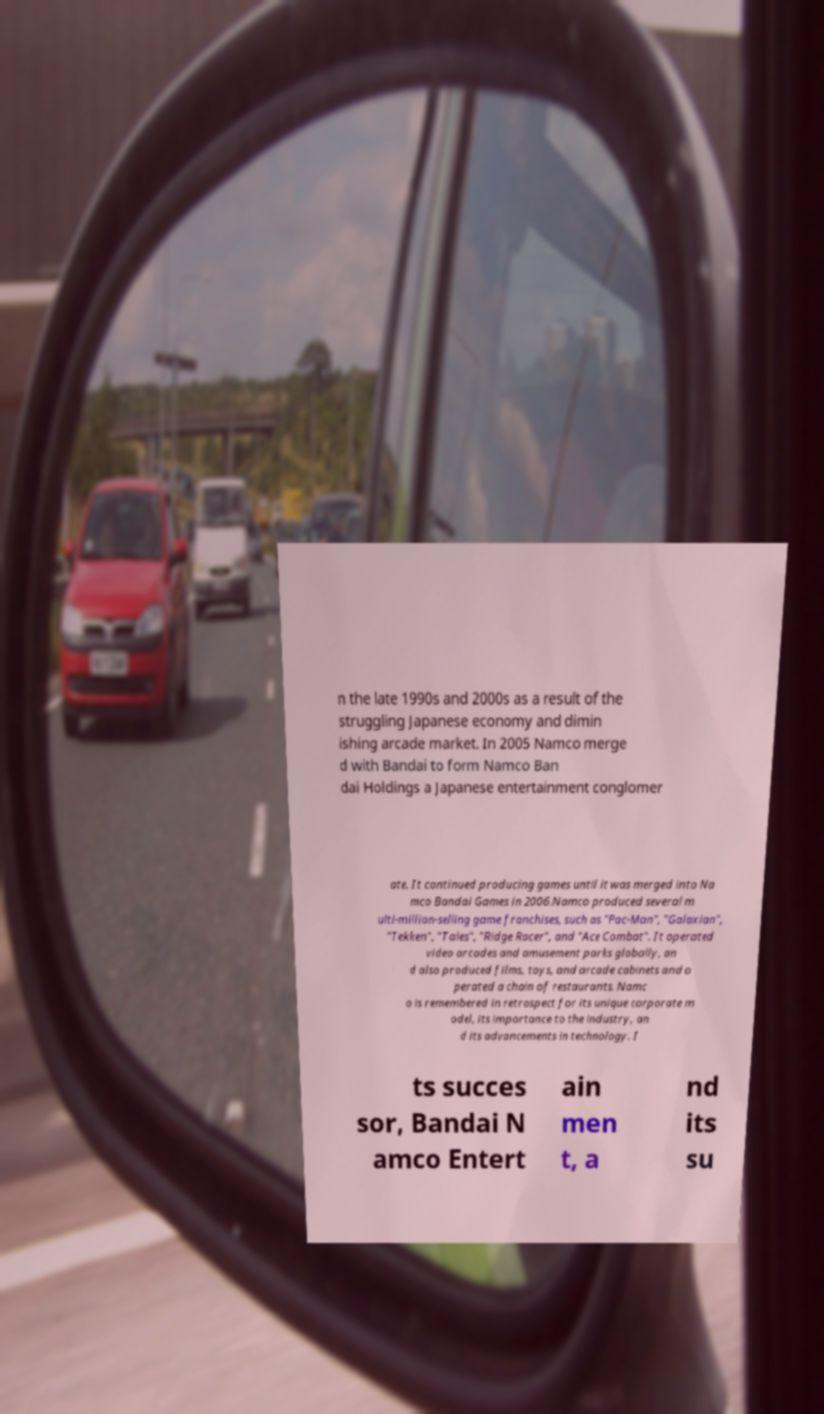Could you assist in decoding the text presented in this image and type it out clearly? n the late 1990s and 2000s as a result of the struggling Japanese economy and dimin ishing arcade market. In 2005 Namco merge d with Bandai to form Namco Ban dai Holdings a Japanese entertainment conglomer ate. It continued producing games until it was merged into Na mco Bandai Games in 2006.Namco produced several m ulti-million-selling game franchises, such as "Pac-Man", "Galaxian", "Tekken", "Tales", "Ridge Racer", and "Ace Combat". It operated video arcades and amusement parks globally, an d also produced films, toys, and arcade cabinets and o perated a chain of restaurants. Namc o is remembered in retrospect for its unique corporate m odel, its importance to the industry, an d its advancements in technology. I ts succes sor, Bandai N amco Entert ain men t, a nd its su 